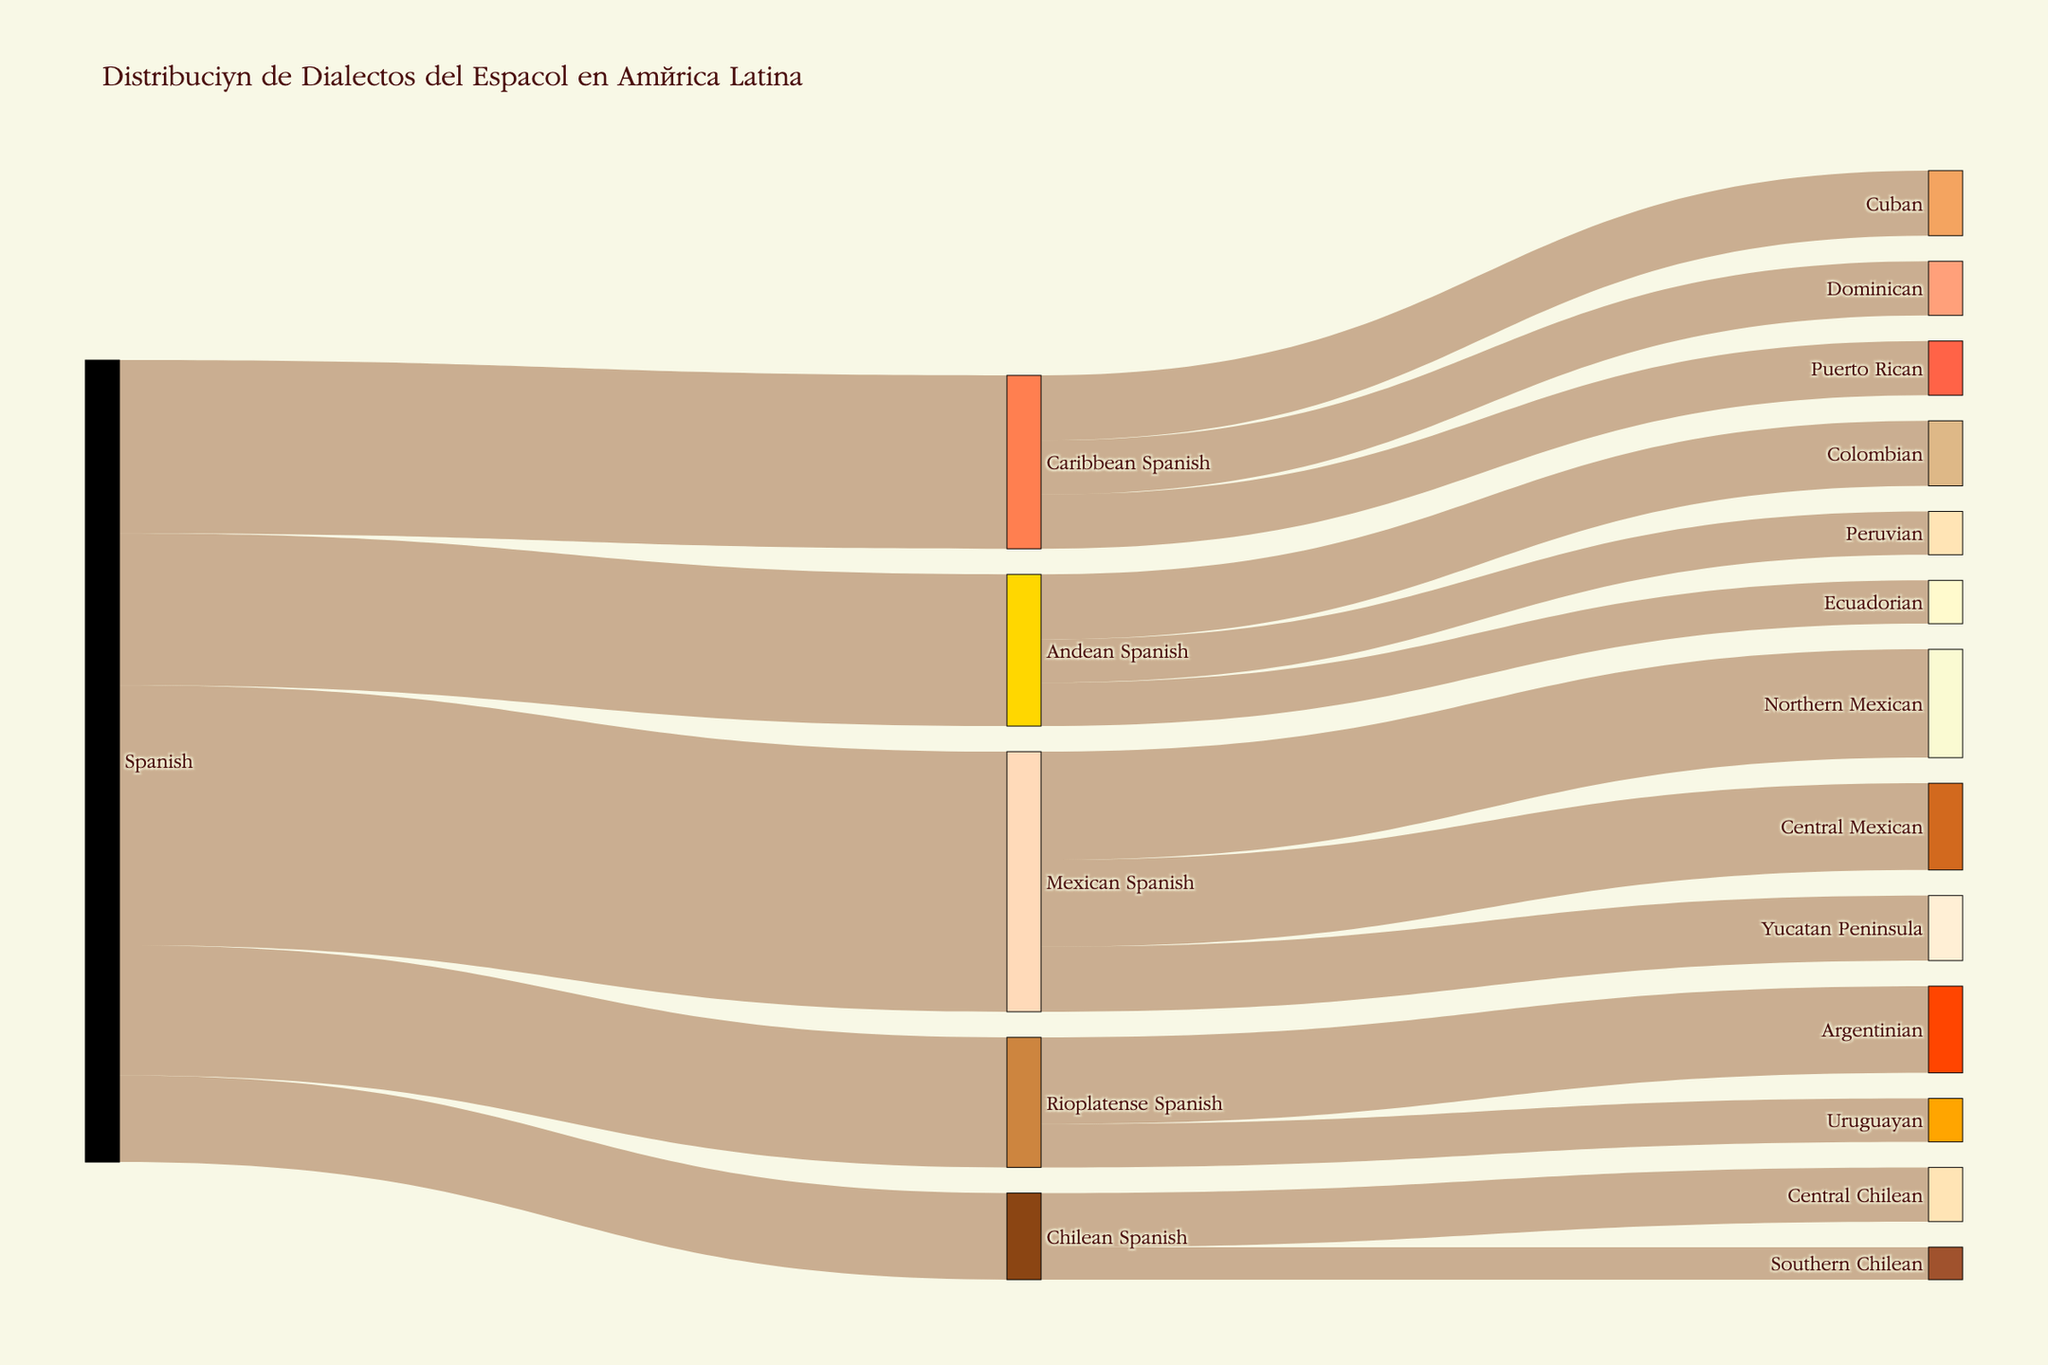what is the total value for Mexican Spanish dialects? From the figure, you can see Mexican Spanish splits into Northern Mexican, Central Mexican, and Yucatan Peninsula with values of 50, 40, and 30 respectively. Summing these values: 50 + 40 + 30 = 120
Answer: 120 How many dialect groups does Spanish branch into in Latin America? The major branches from Spanish include Mexican Spanish, Caribbean Spanish, Andean Spanish, Rioplatense Spanish, and Chilean Spanish. Counting these groups, we get 5
Answer: 5 Which dialect group from Andean Spanish has the highest value? Andean Spanish branches into Colombian, Ecuadorian, and Peruvian dialects with values of 30, 20, and 20 respectively. Thus, the highest value is for the Colombian dialect
Answer: Colombian Does Caribbean Spanish have a higher total value than Andean Spanish? The total value of Caribbean Spanish (80) and Andean Spanish (70) are provided directly by the arrows from Spanish. Comparing these totals, Caribbean Spanish (80) is greater than Andean Spanish (70)
Answer: Yes How does the value for Central Chilean compare to Southern Chilean? From the dialexts under Chilean Spanish: Central Chilean has a value of 25 and Southern Chilean has 15. Comparing these, Central Chilean (25) has a higher value than Southern Chilean (15)
Answer: Central Chilean has a higher value What is the combined value for all dialects in the Caribbean Spanish group? The values for Cuban, Puerto Rican, and Dominican are 30, 25, and 25 respectively. Summing these values: 30 + 25 + 25 = 80
Answer: 80 Which region has the smallest value among the direct branches of Spanish? From the values of the main dialects, the smallest value is for Chilean Spanish with a value of 40
Answer: Chilean Spanish If we merge the values for Rioplatense Spanish regions, what is the combined total? Rioplatense Spanish branches into Argentinian and Uruguayan with values of 40 and 20. Summing these values: 40 + 20 = 60
Answer: 60 Compare the value difference between Northern Mexican and Yucatan Peninsula dialects. The values for Northern Mexican and Yucatan Peninsula are 50 and 30. Calculating the difference: 50 - 30 = 20
Answer: 20 How many sub-dialects branch from Andean Spanish? Andean Spanish splits into Colombian, Ecuadorian, and Peruvian dialects. Counting these branches, there are 3 sub-dialects
Answer: 3 